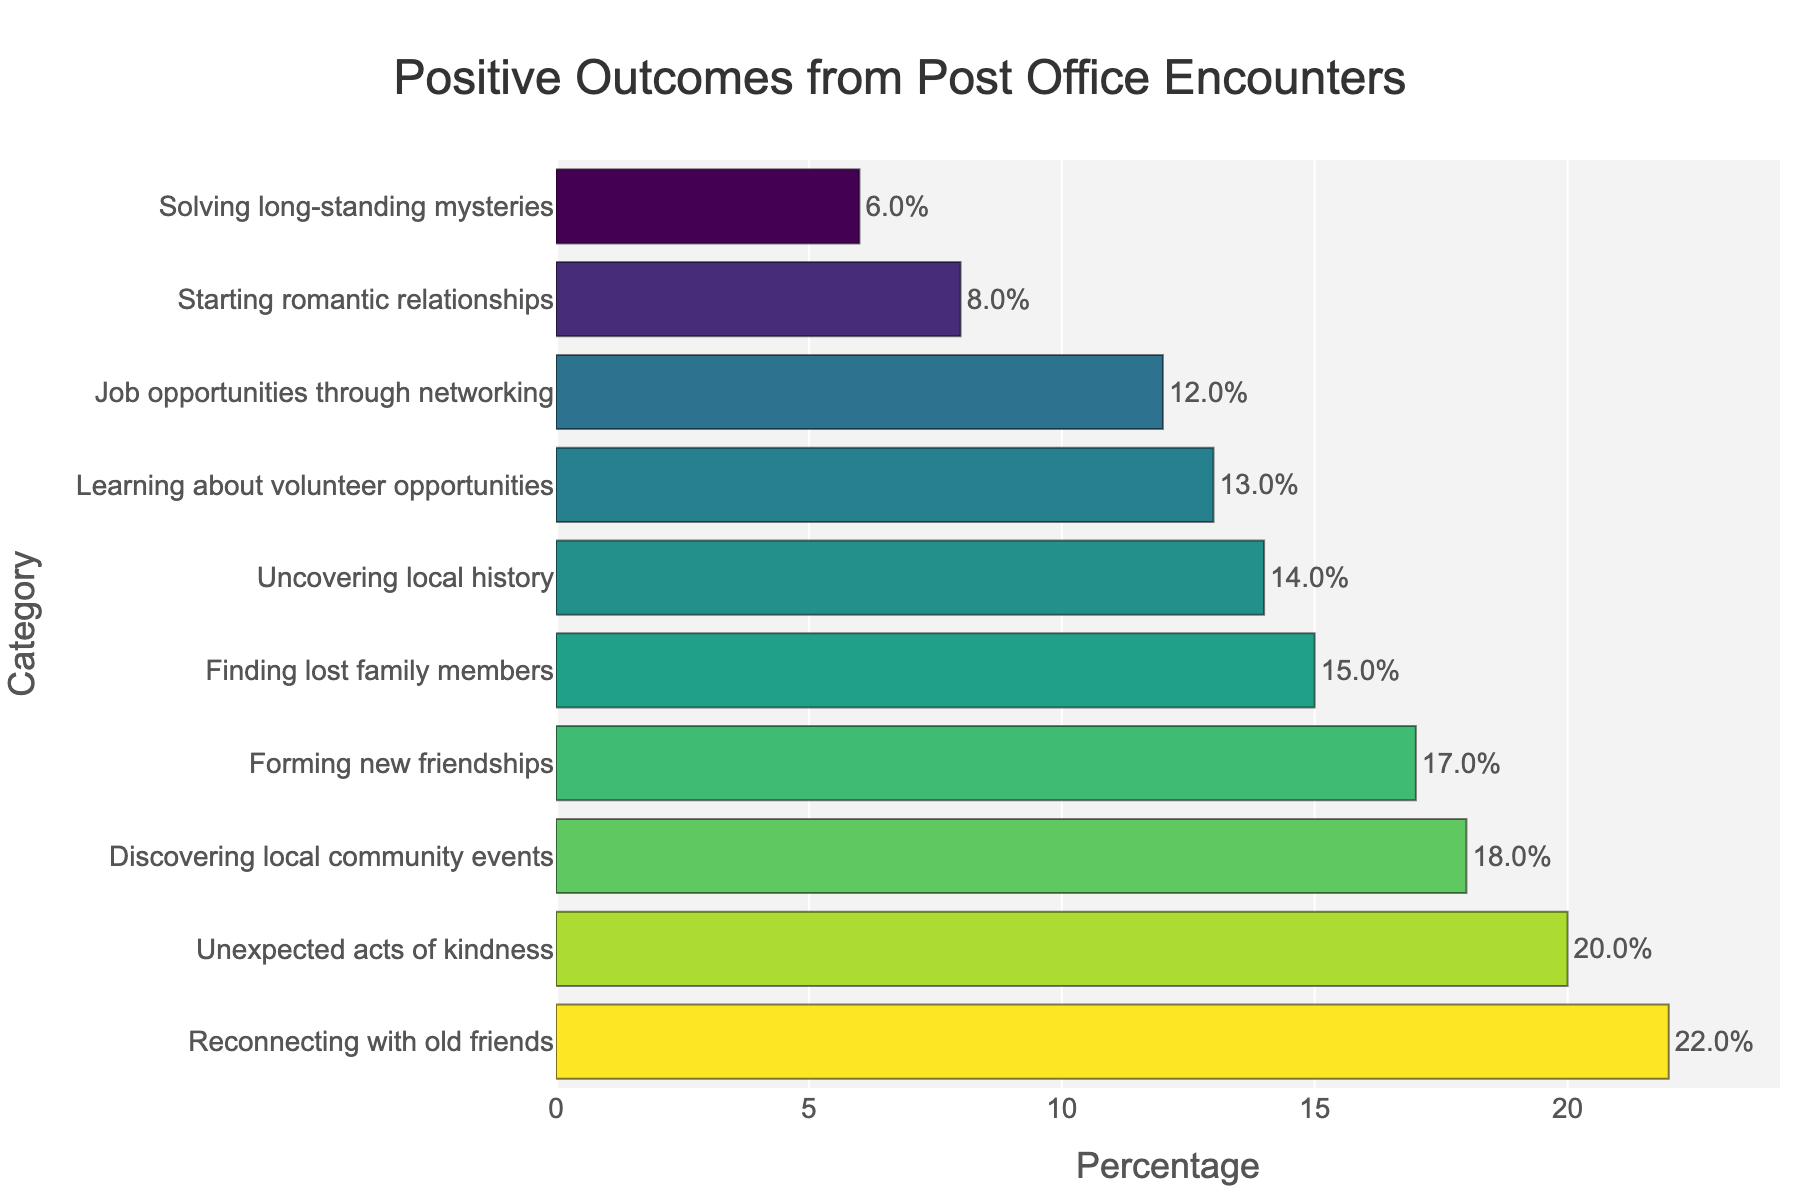What percentage of positive outcomes are related to starting romantic relationships? Look for the bar labeled "Starting romantic relationships" on the y-axis and read the percentage value at the end of the corresponding bar on the x-axis.
Answer: 8% Which category has the highest percentage of positive outcomes, and what is that percentage? Identify the longest bar in the chart, which represents the category with the highest percentage. Then, read the percentage value at the end of this bar on the x-axis.
Answer: Reconnecting with old friends, 22% Which outcome has a higher percentage: Finding lost family members or Forming new friendships? Compare the lengths of the bars corresponding to "Finding lost family members" and "Forming new friendships." The bar that extends further to the right represents the higher percentage.
Answer: Forming new friendships What is the total percentage of outcomes related to community events, volunteer opportunities, and learning local history? Sum the percentages of the categories "Discovering local community events" (18%), "Learning about volunteer opportunities" (13%), and "Uncovering local history" (14%).
Answer: 45% Which category has a smaller percentage: Solving long-standing mysteries or Uncovering local history? Compare the lengths of the bars corresponding to "Solving long-standing mysteries" and "Uncovering local history." The shorter bar represents the smaller percentage.
Answer: Solving long-standing mysteries By how much does the percentage of unexpected acts of kindness exceed that of job opportunities through networking? Subtract the percentage of "Job opportunities through networking" (12%) from "Unexpected acts of kindness" (20%).
Answer: 8% What is the median percentage value of all listed categories? Arrange the percentages in numerical order: 6%, 8%, 12%, 13%, 14%, 15%, 17%, 18%, 20%, 22%. Since there are 10 categories, the median is the average of the 5th and 6th values: (14% + 15%) / 2.
Answer: 14.5% How many categories have a percentage greater than 15%? Count the number of categories whose bars extend beyond the 15% mark on the x-axis.
Answer: 5 